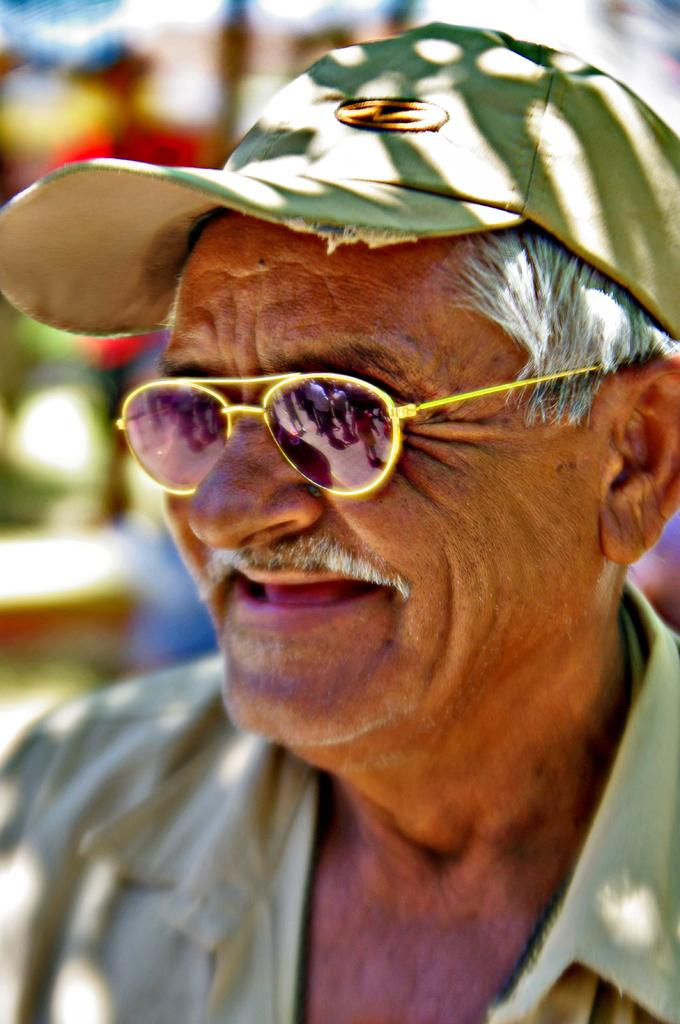Who is the main subject in the image? There is an old man in the image. What is the old man wearing on his head? The old man is wearing a cap. What type of eyewear does the old man have? The old man has goggles. What expression does the old man have in the image? The old man is smiling. How would you describe the background in the image? The background in the image is blurred. What type of cabbage is the old man holding in the image? There is no cabbage present in the image; the old man is not holding any vegetables. What color is the umbrella that the old man is using in the image? There is no umbrella present in the image; the old man is not using any umbrella. 